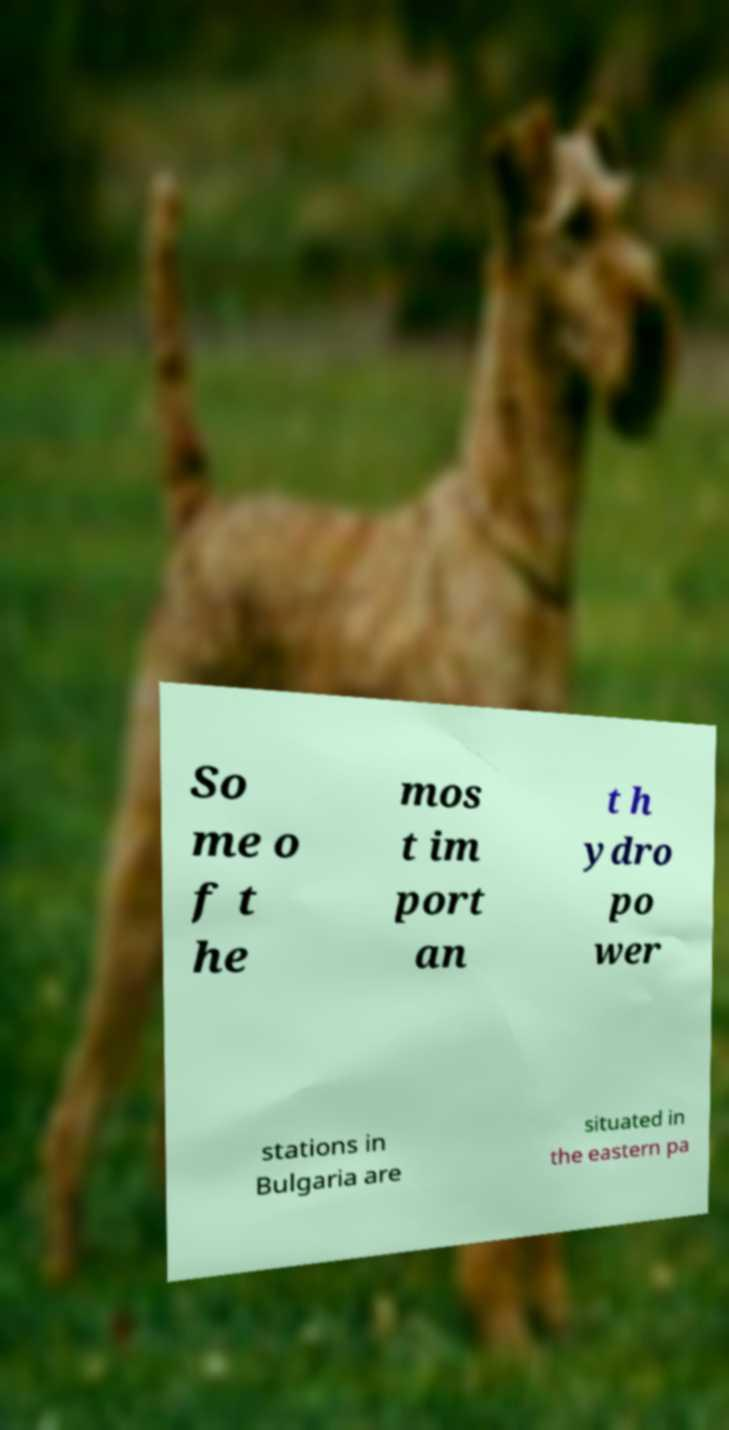Could you extract and type out the text from this image? So me o f t he mos t im port an t h ydro po wer stations in Bulgaria are situated in the eastern pa 